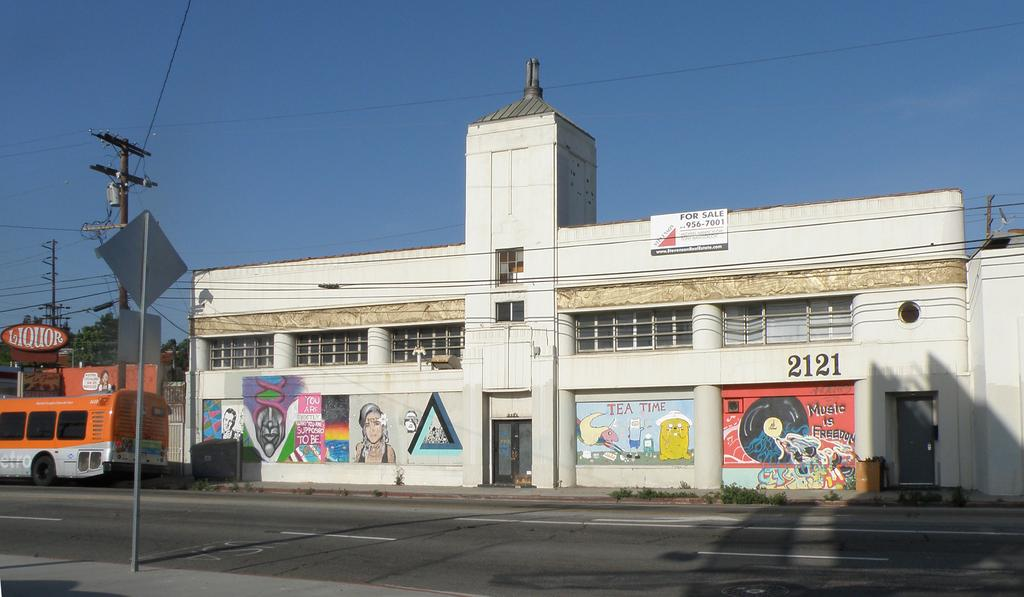What is in the foreground of the image? There is a road in the foreground of the image. What is located near the road? There is a sign board near the road. What can be seen in the background of the image? There is a vehicle, a building, trees, cables, and the sky visible in the background of the image. What type of paint is being used to create the waves in the image? There are no waves present in the image, so there is no paint being used for that purpose. 